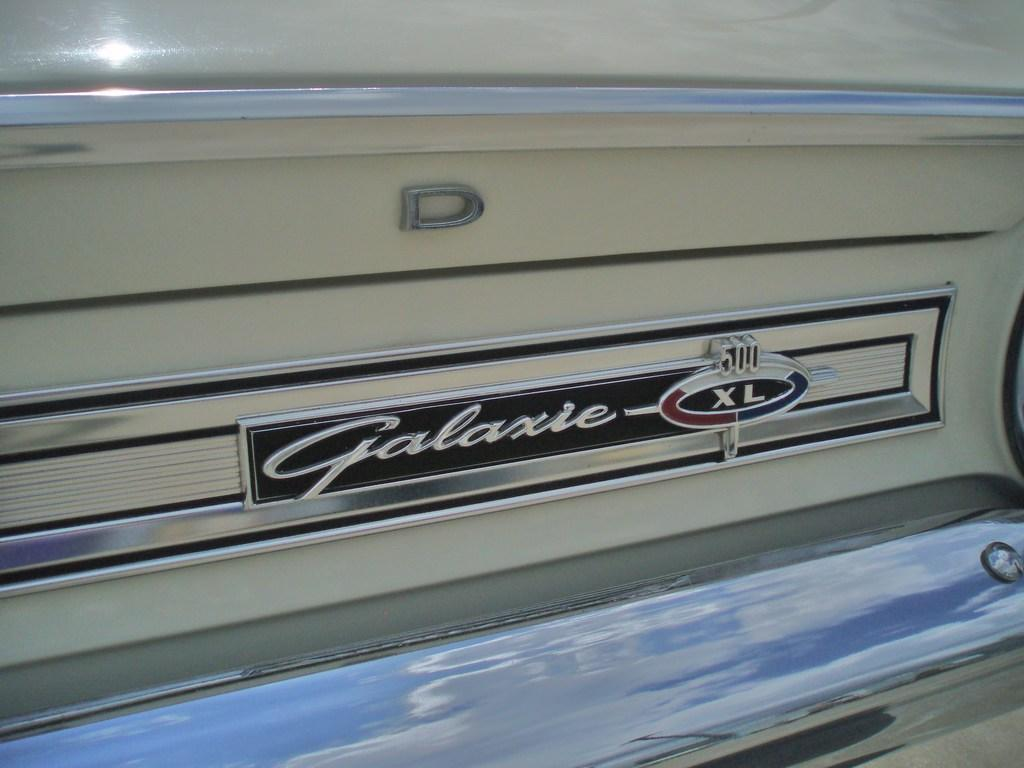What is the main subject in the center of the image? There is a vehicle in the center of the image. Can you describe any additional features of the vehicle? Yes, there is text on the vehicle. Can you see a bear playing on the seashore in the image? No, there is no bear or seashore present in the image. The image only features a vehicle with text on it. 